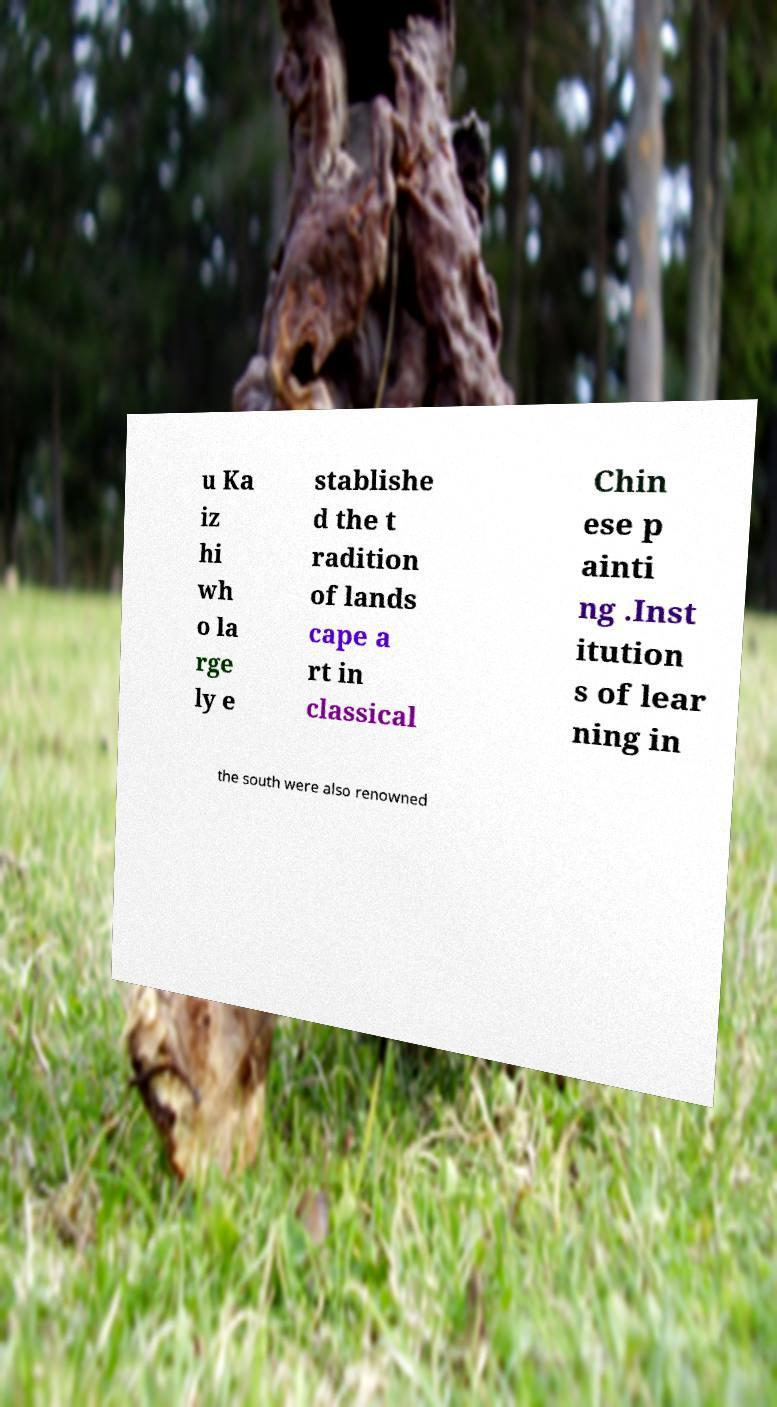Could you extract and type out the text from this image? u Ka iz hi wh o la rge ly e stablishe d the t radition of lands cape a rt in classical Chin ese p ainti ng .Inst itution s of lear ning in the south were also renowned 